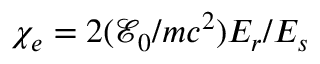Convert formula to latex. <formula><loc_0><loc_0><loc_500><loc_500>\chi _ { e } = 2 ( \mathcal { E } _ { 0 } / m c ^ { 2 } ) E _ { r } / E _ { s }</formula> 